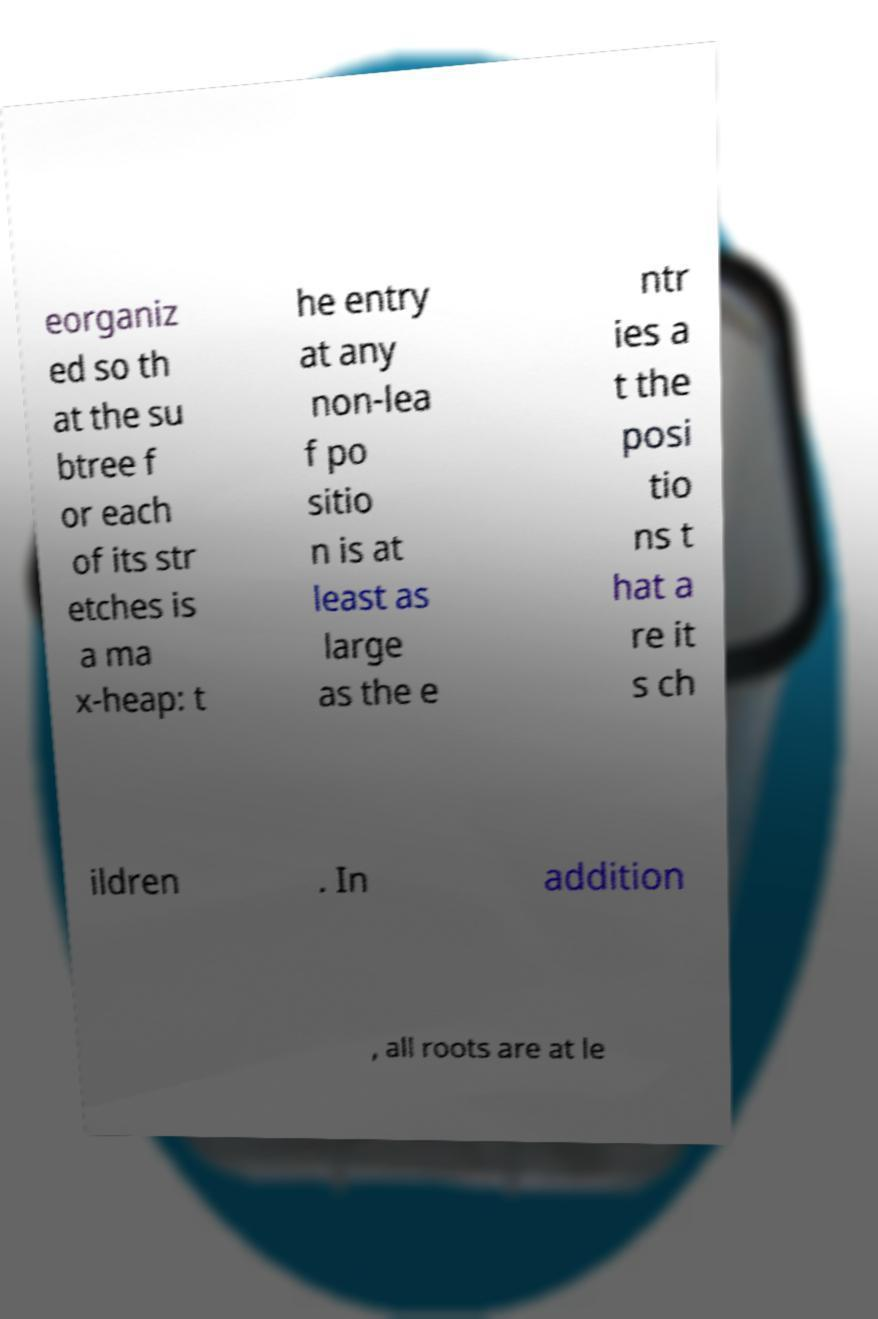Can you accurately transcribe the text from the provided image for me? eorganiz ed so th at the su btree f or each of its str etches is a ma x-heap: t he entry at any non-lea f po sitio n is at least as large as the e ntr ies a t the posi tio ns t hat a re it s ch ildren . In addition , all roots are at le 